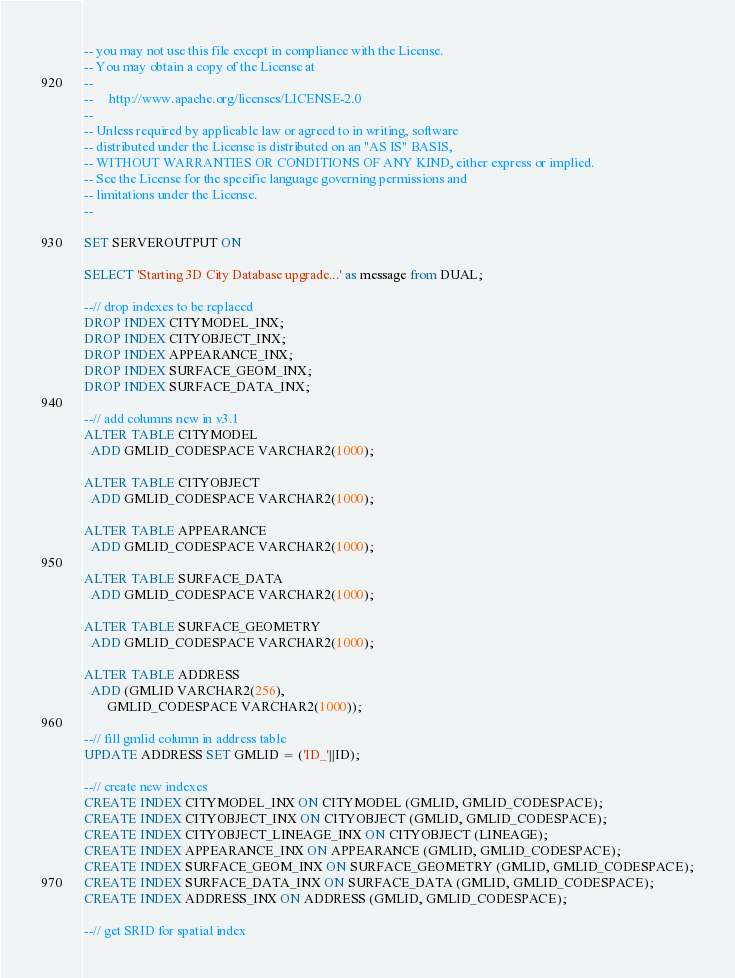Convert code to text. <code><loc_0><loc_0><loc_500><loc_500><_SQL_>-- you may not use this file except in compliance with the License.
-- You may obtain a copy of the License at
-- 
--     http://www.apache.org/licenses/LICENSE-2.0
--     
-- Unless required by applicable law or agreed to in writing, software
-- distributed under the License is distributed on an "AS IS" BASIS,
-- WITHOUT WARRANTIES OR CONDITIONS OF ANY KIND, either express or implied.
-- See the License for the specific language governing permissions and
-- limitations under the License.
--

SET SERVEROUTPUT ON

SELECT 'Starting 3D City Database upgrade...' as message from DUAL;

--// drop indexes to be replaced
DROP INDEX CITYMODEL_INX;
DROP INDEX CITYOBJECT_INX;
DROP INDEX APPEARANCE_INX;
DROP INDEX SURFACE_GEOM_INX;
DROP INDEX SURFACE_DATA_INX;

--// add columns new in v3.1
ALTER TABLE CITYMODEL
  ADD GMLID_CODESPACE VARCHAR2(1000);

ALTER TABLE CITYOBJECT
  ADD GMLID_CODESPACE VARCHAR2(1000);

ALTER TABLE APPEARANCE
  ADD GMLID_CODESPACE VARCHAR2(1000);

ALTER TABLE SURFACE_DATA
  ADD GMLID_CODESPACE VARCHAR2(1000);
  
ALTER TABLE SURFACE_GEOMETRY
  ADD GMLID_CODESPACE VARCHAR2(1000);

ALTER TABLE ADDRESS
  ADD (GMLID VARCHAR2(256),
       GMLID_CODESPACE VARCHAR2(1000));

--// fill gmlid column in address table
UPDATE ADDRESS SET GMLID = ('ID_'||ID);

--// create new indexes
CREATE INDEX CITYMODEL_INX ON CITYMODEL (GMLID, GMLID_CODESPACE);
CREATE INDEX CITYOBJECT_INX ON CITYOBJECT (GMLID, GMLID_CODESPACE);
CREATE INDEX CITYOBJECT_LINEAGE_INX ON CITYOBJECT (LINEAGE);
CREATE INDEX APPEARANCE_INX ON APPEARANCE (GMLID, GMLID_CODESPACE);
CREATE INDEX SURFACE_GEOM_INX ON SURFACE_GEOMETRY (GMLID, GMLID_CODESPACE);
CREATE INDEX SURFACE_DATA_INX ON SURFACE_DATA (GMLID, GMLID_CODESPACE);
CREATE INDEX ADDRESS_INX ON ADDRESS (GMLID, GMLID_CODESPACE);

--// get SRID for spatial index</code> 